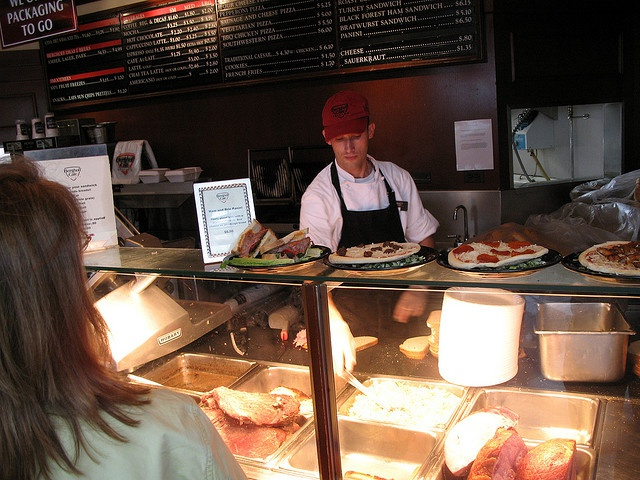Describe the objects in this image and their specific colors. I can see people in black, maroon, darkgray, and gray tones, people in black, maroon, darkgray, and white tones, pizza in black, khaki, tan, lightyellow, and brown tones, pizza in black, maroon, tan, darkgray, and gray tones, and pizza in black, tan, gray, and darkgray tones in this image. 